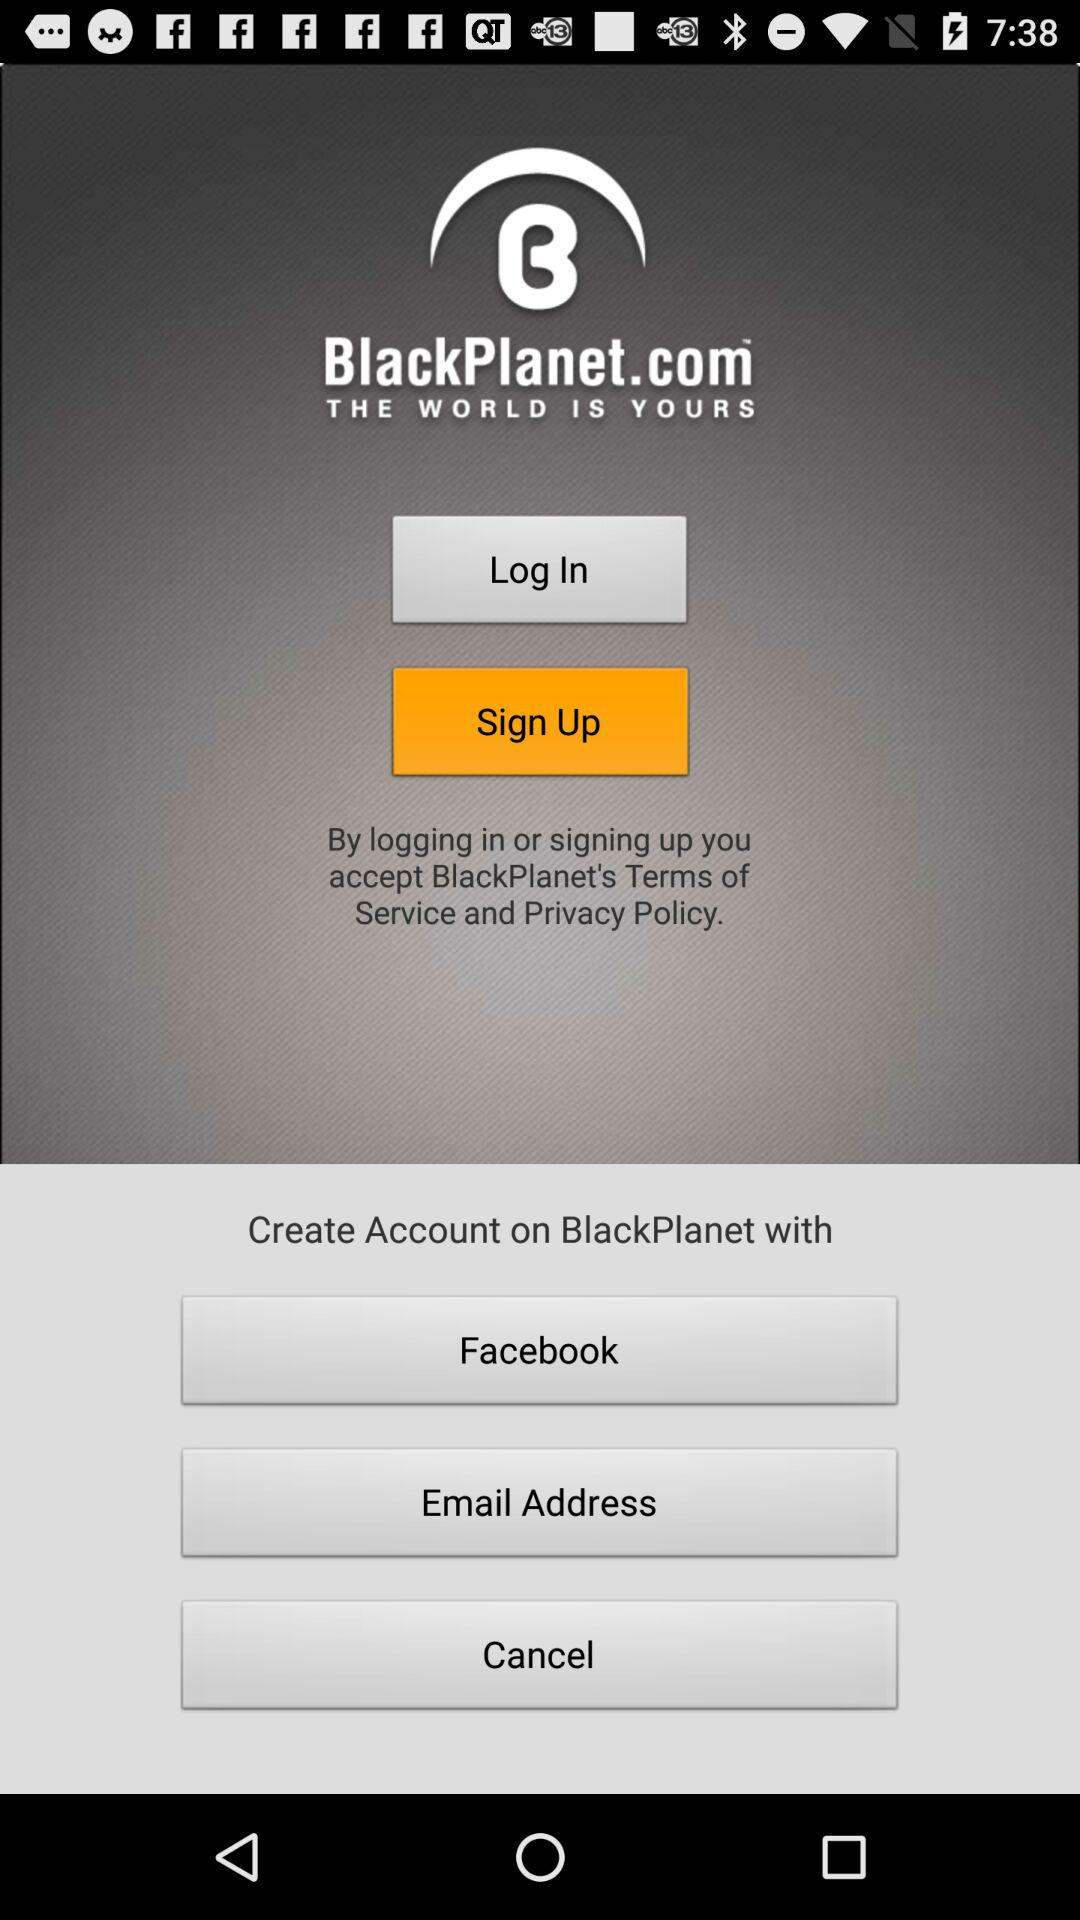What is the name of the application? The name of the application is "BlackPlanet". 